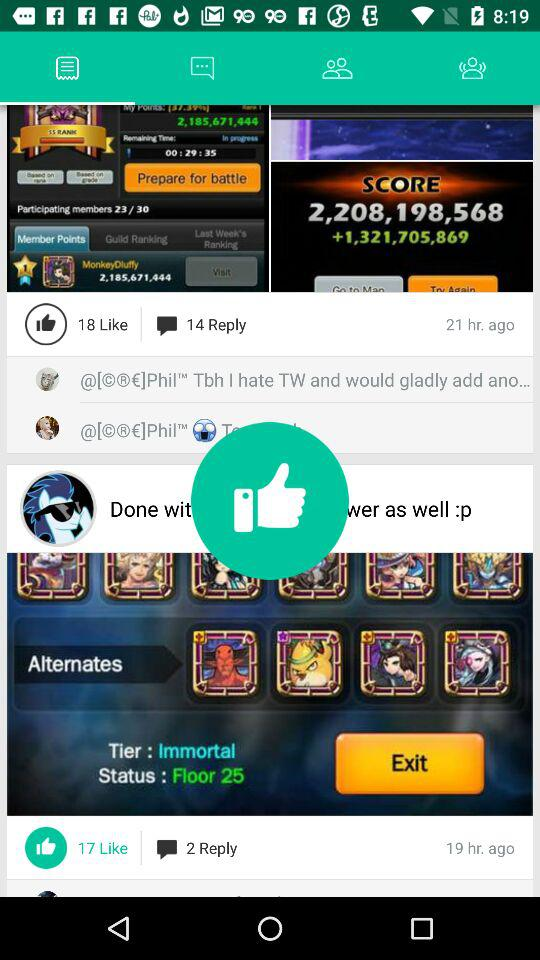How many have commented?
When the provided information is insufficient, respond with <no answer>. <no answer> 